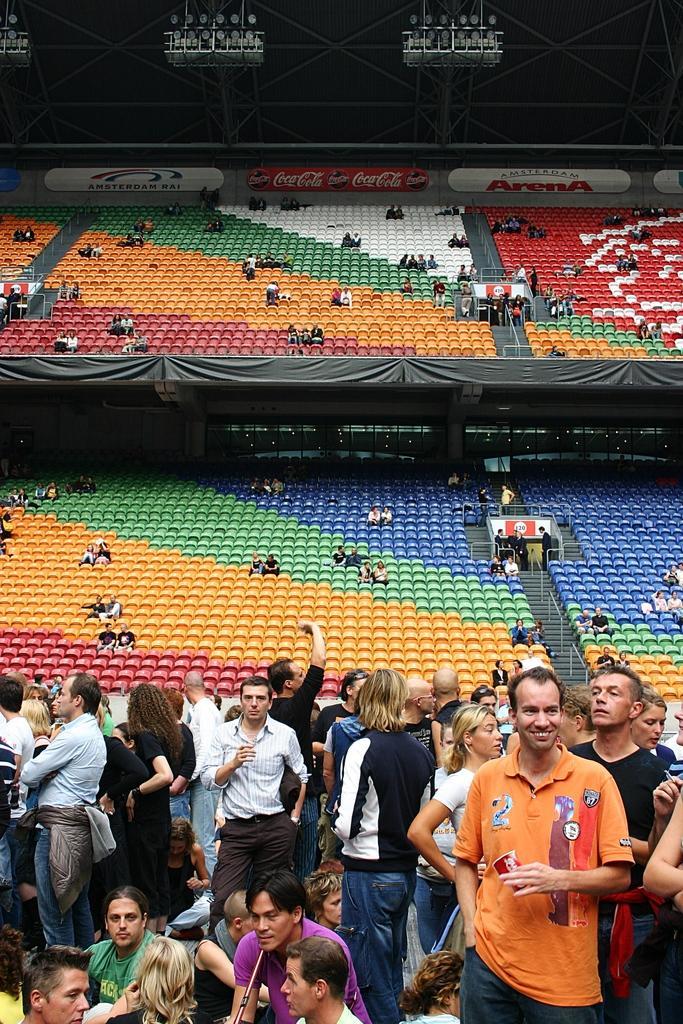Could you give a brief overview of what you see in this image? In this image there are a few people in a stadium, behind them there are a few people seated in chairs. 